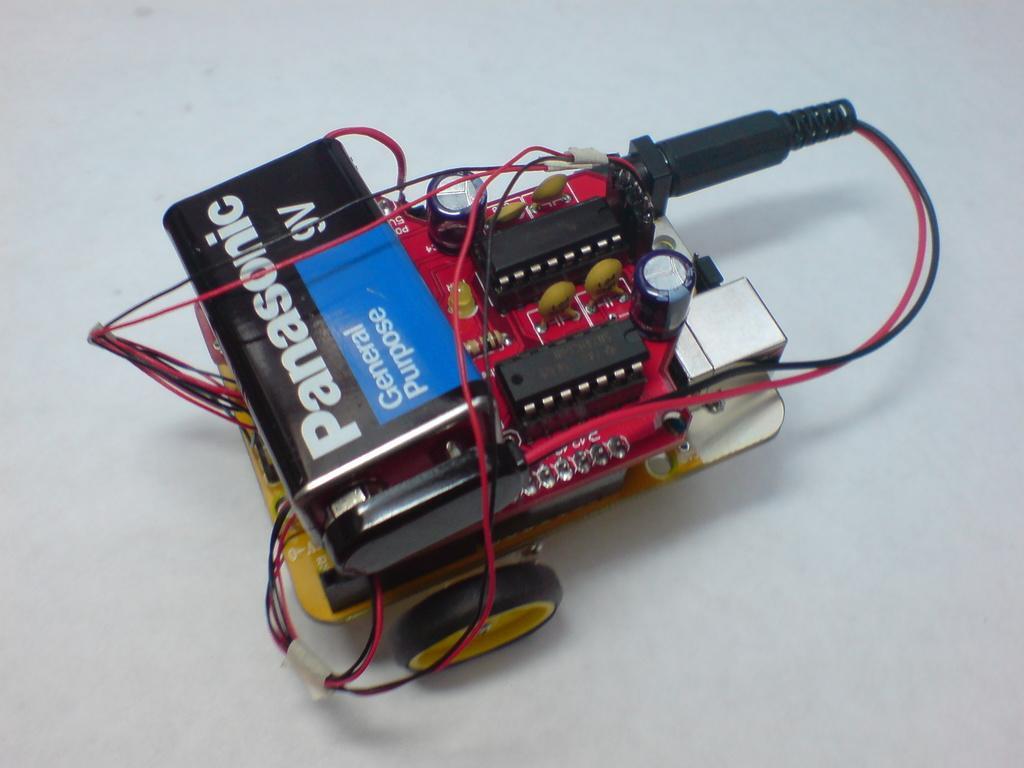Describe this image in one or two sentences. In this image we can see a spare part placed on the surface. 